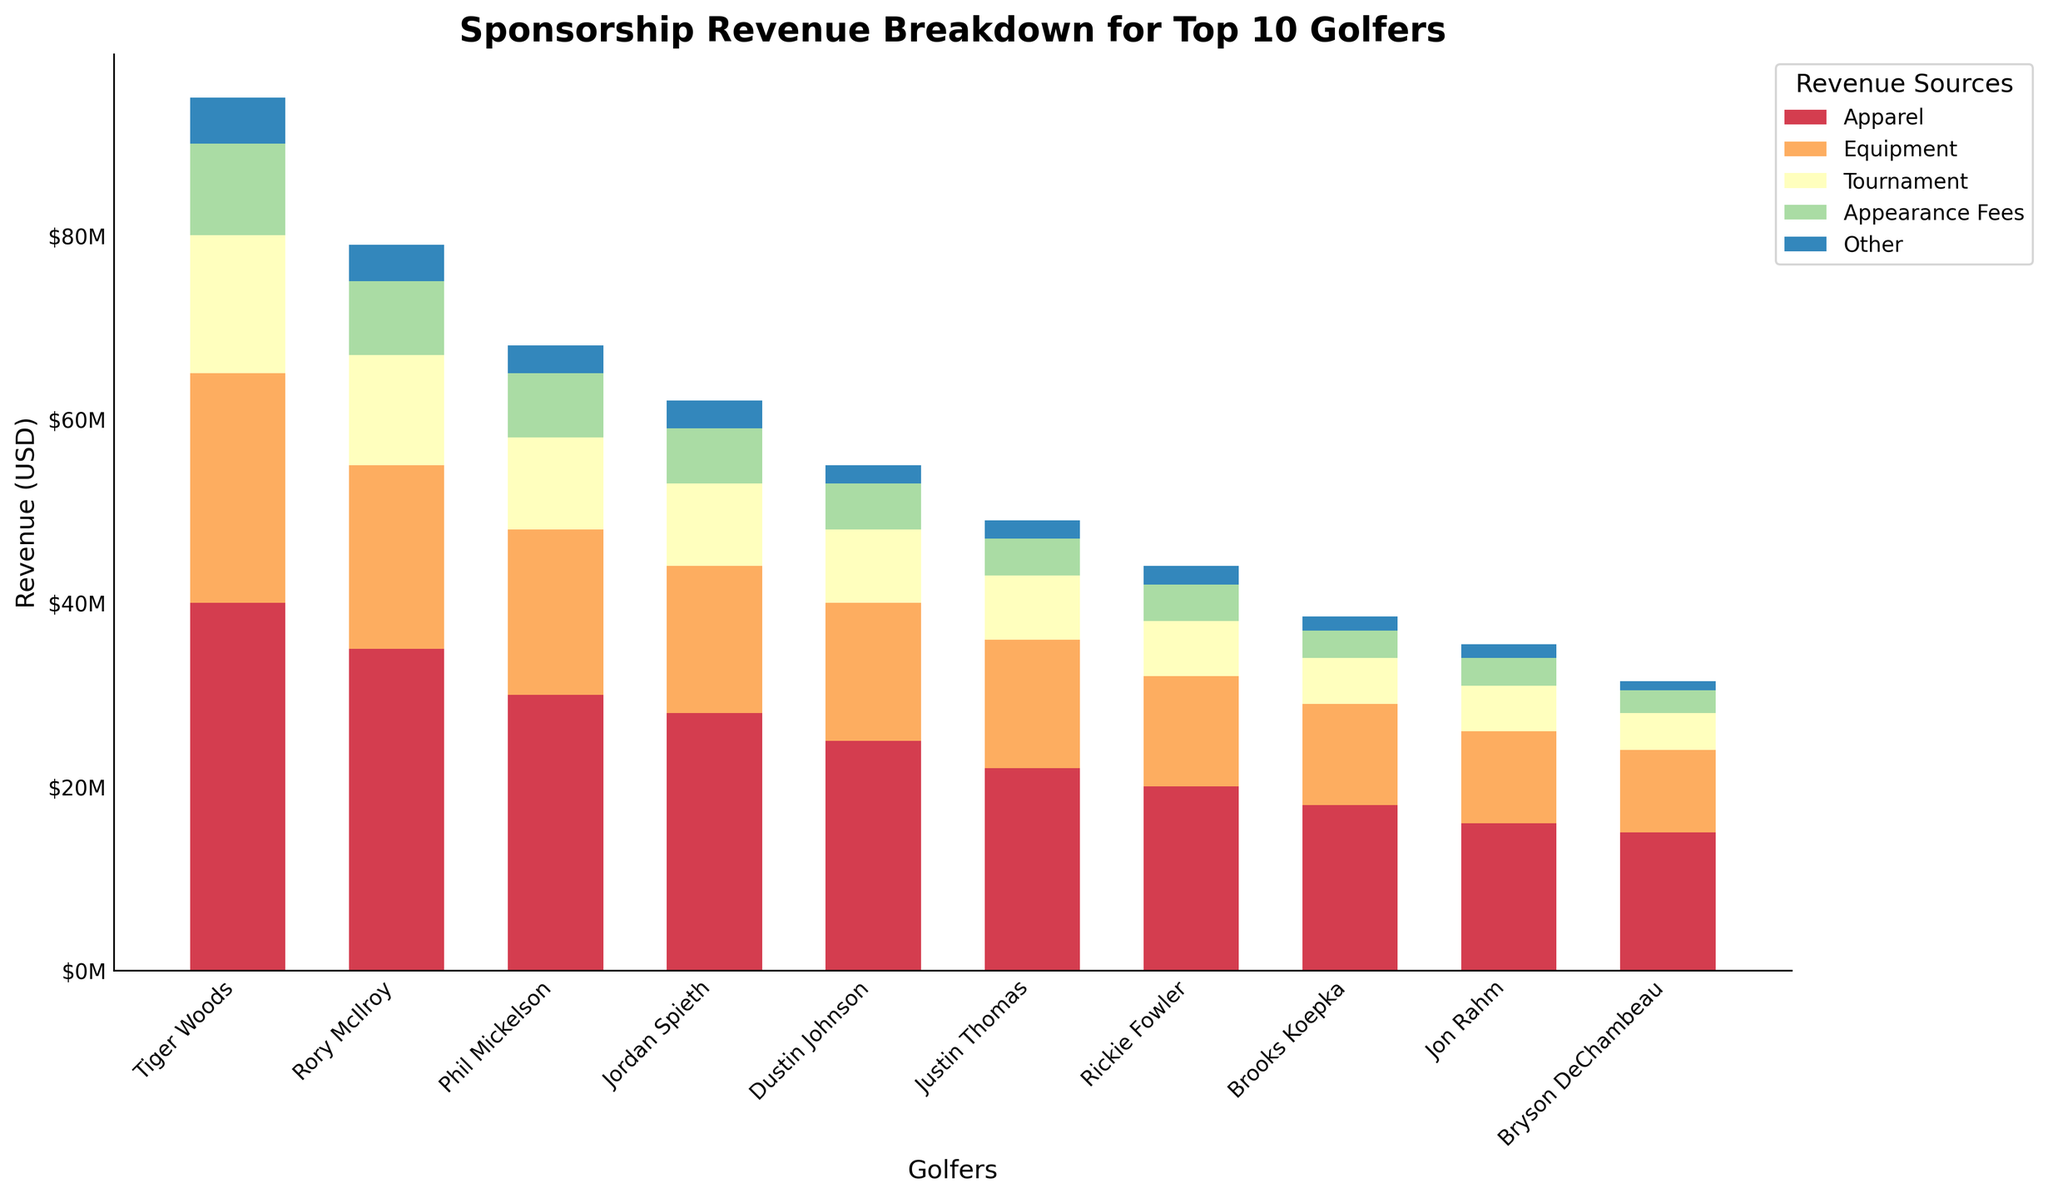Which golfer has the highest total sponsorship revenue? Observe the height of the stacked bars. Tiger Woods has the tallest bar, indicating he has the highest total sponsorship revenue.
Answer: Tiger Woods Who has a higher revenue from Appearance Fees: Dustin Johnson or Jordan Spieth? Compare the blue sections of the bars for Dustin Johnson and Jordan Spieth. Jordan Spieth's blue section is taller.
Answer: Jordan Spieth What is the total combined revenue from Equipment for Rory McIlroy and Phil Mickelson? Add the lengths of the purple sections for Rory McIlroy and Phil Mickelson. Rory McIlroy has 20M and Phil Mickelson has 18M, so the total is 20M + 18M.
Answer: 38M Which revenue type represents the smallest portion of Justin Thomas's total sponsorship? Examine Justin Thomas's bar and find the shortest section. The teal section (Appearance Fees) is the shortest.
Answer: Appearance Fees What is the difference in revenue from Apparel between Tiger Woods and Rickie Fowler? Subtract the height of Rickie Fowler's Apparel section from Tiger Woods's. Tiger Woods has 40M and Rickie Fowler has 20M, so the difference is 40M - 20M.
Answer: 20M Identify the golfer with the lowest revenue from the "Other" category. Look for the shortest grey section among all the golfers. Dustin Johnson has the shortest grey section.
Answer: Dustin Johnson Which two golfers have the closest total sponsorship revenues? Compare the heights of the stacked bars to find the closest ones in total height. Justin Thomas and Rickie Fowler have similar total heights.
Answer: Justin Thomas and Rickie Fowler How does the revenue from Tournaments compare between Brooks Koepka and Jon Rahm? Compare the height of the green sections for both golfers. Both Brooks Koepka and Jon Rahm have the green sections that reach the same height.
Answer: Equal What is the average revenue from Appearance Fees for the top 3 golfers? Add the blue sections for the top 3 golfers (Tiger Woods, Rory McIlroy, and Phil Mickelson) and divide by 3. Tiger Woods (10M), Rory McIlroy (8M), and Phil Mickelson (7M) sum up to 25M. The average is 25M / 3.
Answer: 8.33M Which golfer has the highest revenue from Equipment among the top 10 golfers? Identify the purple section with the greatest height. Tiger Woods has the tallest purple section.
Answer: Tiger Woods 